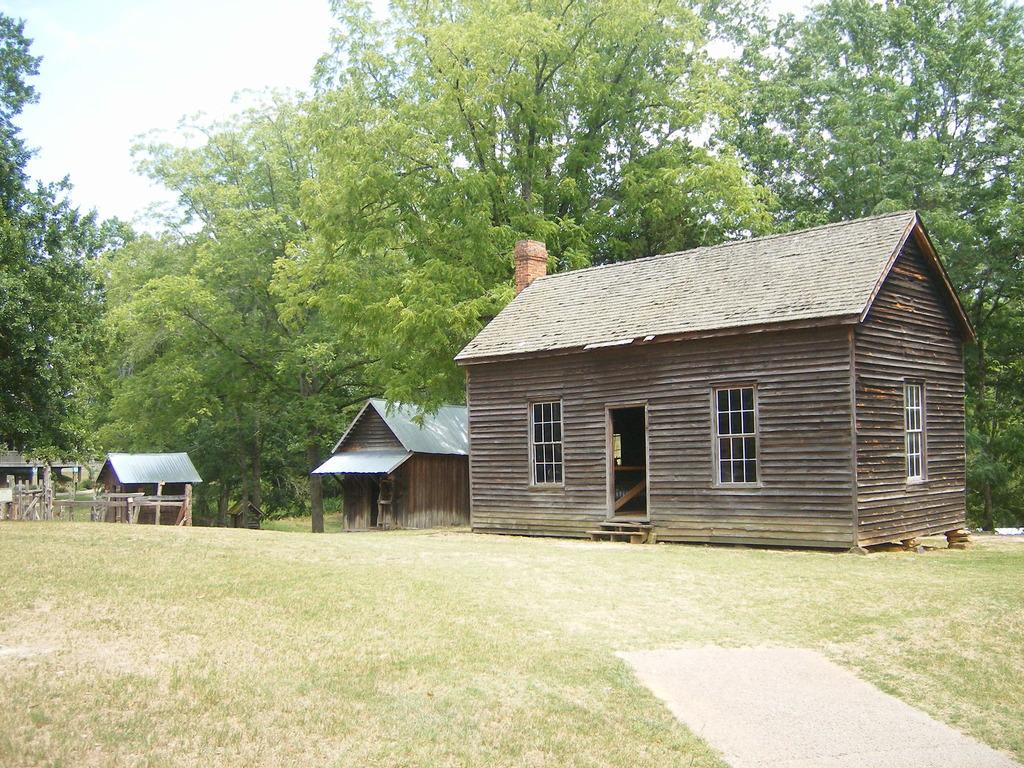What type of structures can be seen in the image? There are houses in the image. What features do the houses have? The houses have roofs and windows. What type of vegetation is visible in the image? There is grass visible in the image. What else can be seen in the image besides the houses and grass? There is a group of trees in the image. What is visible in the background of the image? The sky is visible in the image. What type of scarf is hanging from the tree in the image? There is no scarf present in the image; it only features houses, grass, trees, and the sky. Can you tell me how much honey is being produced by the trees in the image? There is no mention of honey production in the image; it only shows trees and not any bees or hives. 